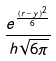Convert formula to latex. <formula><loc_0><loc_0><loc_500><loc_500>\frac { e ^ { \frac { ( r - y ) ^ { 2 } } { 6 } } } { h \sqrt { 6 \pi } }</formula> 